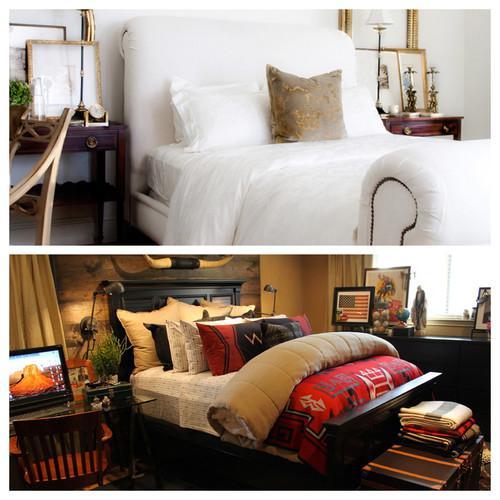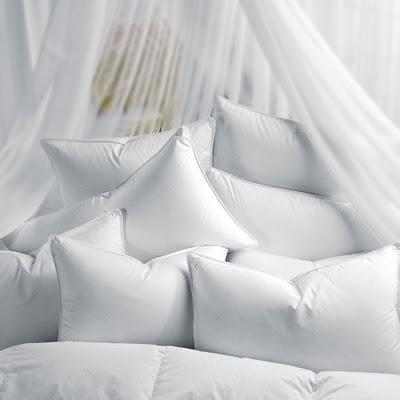The first image is the image on the left, the second image is the image on the right. Assess this claim about the two images: "The bed on the farthest right has mostly solid white pillows.". Correct or not? Answer yes or no. Yes. 